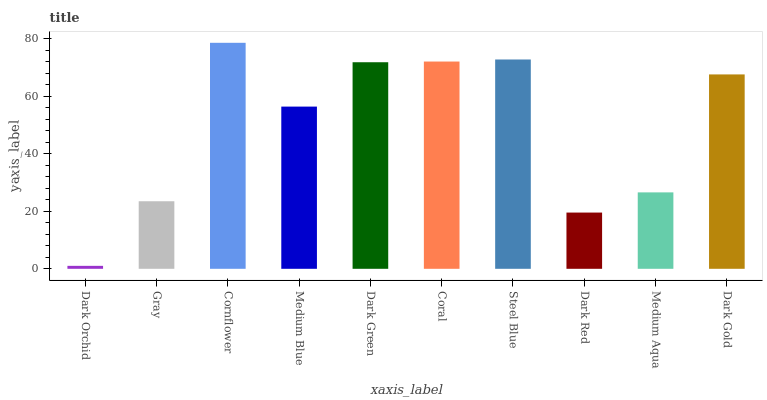Is Dark Orchid the minimum?
Answer yes or no. Yes. Is Cornflower the maximum?
Answer yes or no. Yes. Is Gray the minimum?
Answer yes or no. No. Is Gray the maximum?
Answer yes or no. No. Is Gray greater than Dark Orchid?
Answer yes or no. Yes. Is Dark Orchid less than Gray?
Answer yes or no. Yes. Is Dark Orchid greater than Gray?
Answer yes or no. No. Is Gray less than Dark Orchid?
Answer yes or no. No. Is Dark Gold the high median?
Answer yes or no. Yes. Is Medium Blue the low median?
Answer yes or no. Yes. Is Dark Green the high median?
Answer yes or no. No. Is Dark Orchid the low median?
Answer yes or no. No. 